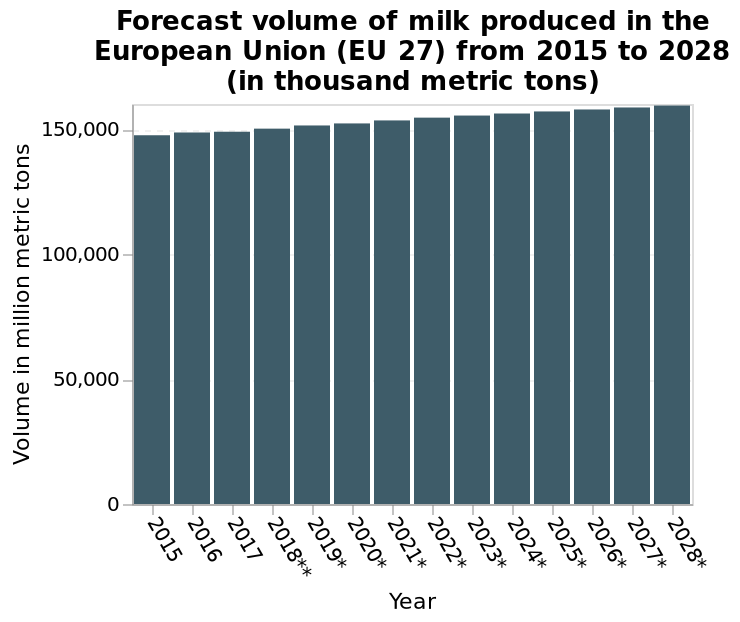<image>
How long is the time period covered by the bar plot?  The bar plot covers the time period from 2015 to 2028. What can be inferred about milk production from the bar chart? From the bar chart, it can be inferred that milk production is expected to have a continuous growth in the coming years. What does the x-axis represent in the bar plot?  The x-axis represents the year in the bar plot. How does milk production change over the years according to the bar chart? According to the bar chart, milk production steadily increases year on year. What is the unit of measurement for the volume of milk produced? The volume of milk produced is measured in thousand metric tons. 